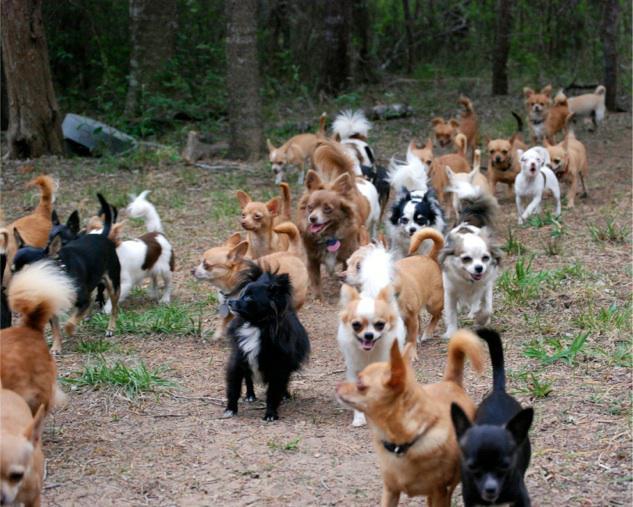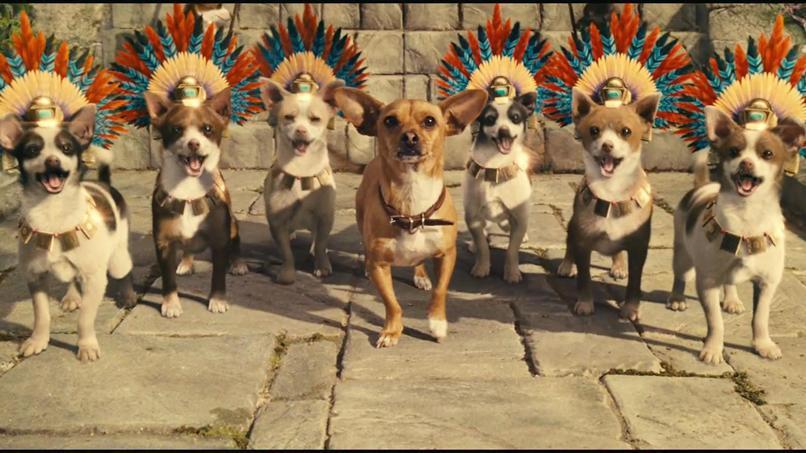The first image is the image on the left, the second image is the image on the right. For the images shown, is this caption "A cat is in the middle of a horizontal row of dogs in one image." true? Answer yes or no. No. The first image is the image on the left, the second image is the image on the right. Examine the images to the left and right. Is the description "There are five dogs in the left picture." accurate? Answer yes or no. No. 